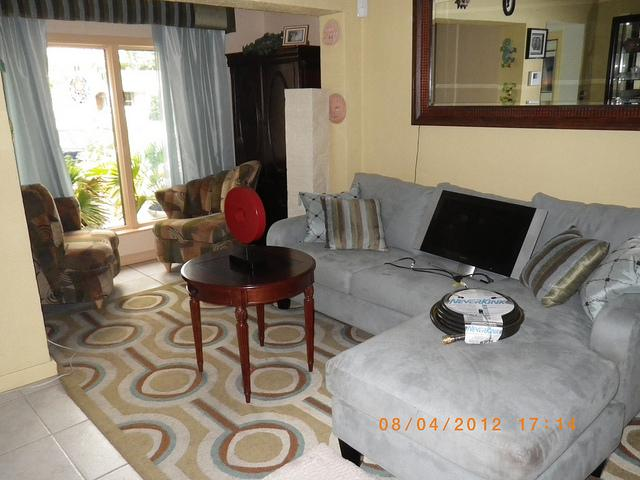What is on the couch?

Choices:
A) apple
B) egg carton
C) hose
D) cat hose 